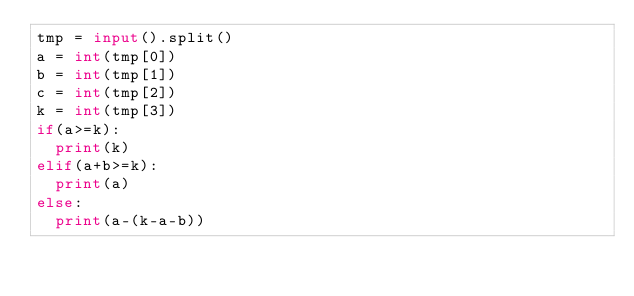Convert code to text. <code><loc_0><loc_0><loc_500><loc_500><_Python_>tmp = input().split()
a = int(tmp[0])
b = int(tmp[1])
c = int(tmp[2])
k = int(tmp[3])
if(a>=k):
  print(k)
elif(a+b>=k):
  print(a)
else:
  print(a-(k-a-b))</code> 